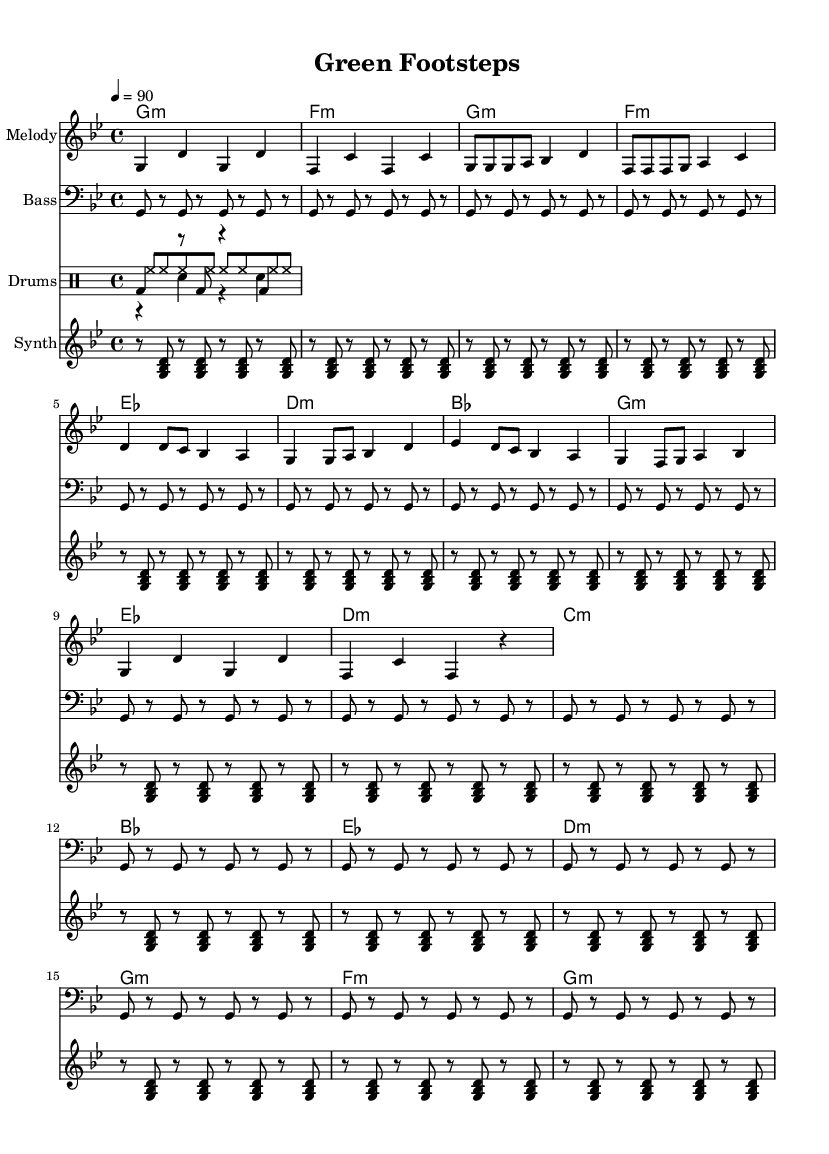What is the key signature of this music? The key signature is G minor, which has two flats (B flat and E flat). This can be identified by the symbol next to the clef at the beginning of the staff.
Answer: G minor What is the time signature of this music? The time signature is 4/4, which is indicated at the beginning of the score. This means there are four beats in each measure and a quarter note gets one beat.
Answer: 4/4 What is the tempo marking for this piece? The tempo marking is 90 BPM (beats per minute), which is specified as "4 = 90" in the tempo section. This indicates the speed of the music.
Answer: 90 How many measures are in the chorus section? The chorus section contains four measures, which can be counted from the notation during that specific section of the music.
Answer: 4 Which section follows the verse? The section that follows the verse is the chorus, as indicated by the structure laid out in the sheet music where the verse is immediately followed by the chorus without interruption.
Answer: Chorus What is the predominant chord used in the introduction? The predominant chord in the introduction is G minor, which is stated at the beginning of the score and sets the harmonic foundation for the first part of the music.
Answer: G minor What special feature identifies this piece as hip-hop? The piece contains a drum pattern that includes kick, snare, and hi-hat, which are typical elements of hip-hop music production, contributing to its distinctive rhythm and groove.
Answer: Drum pattern 